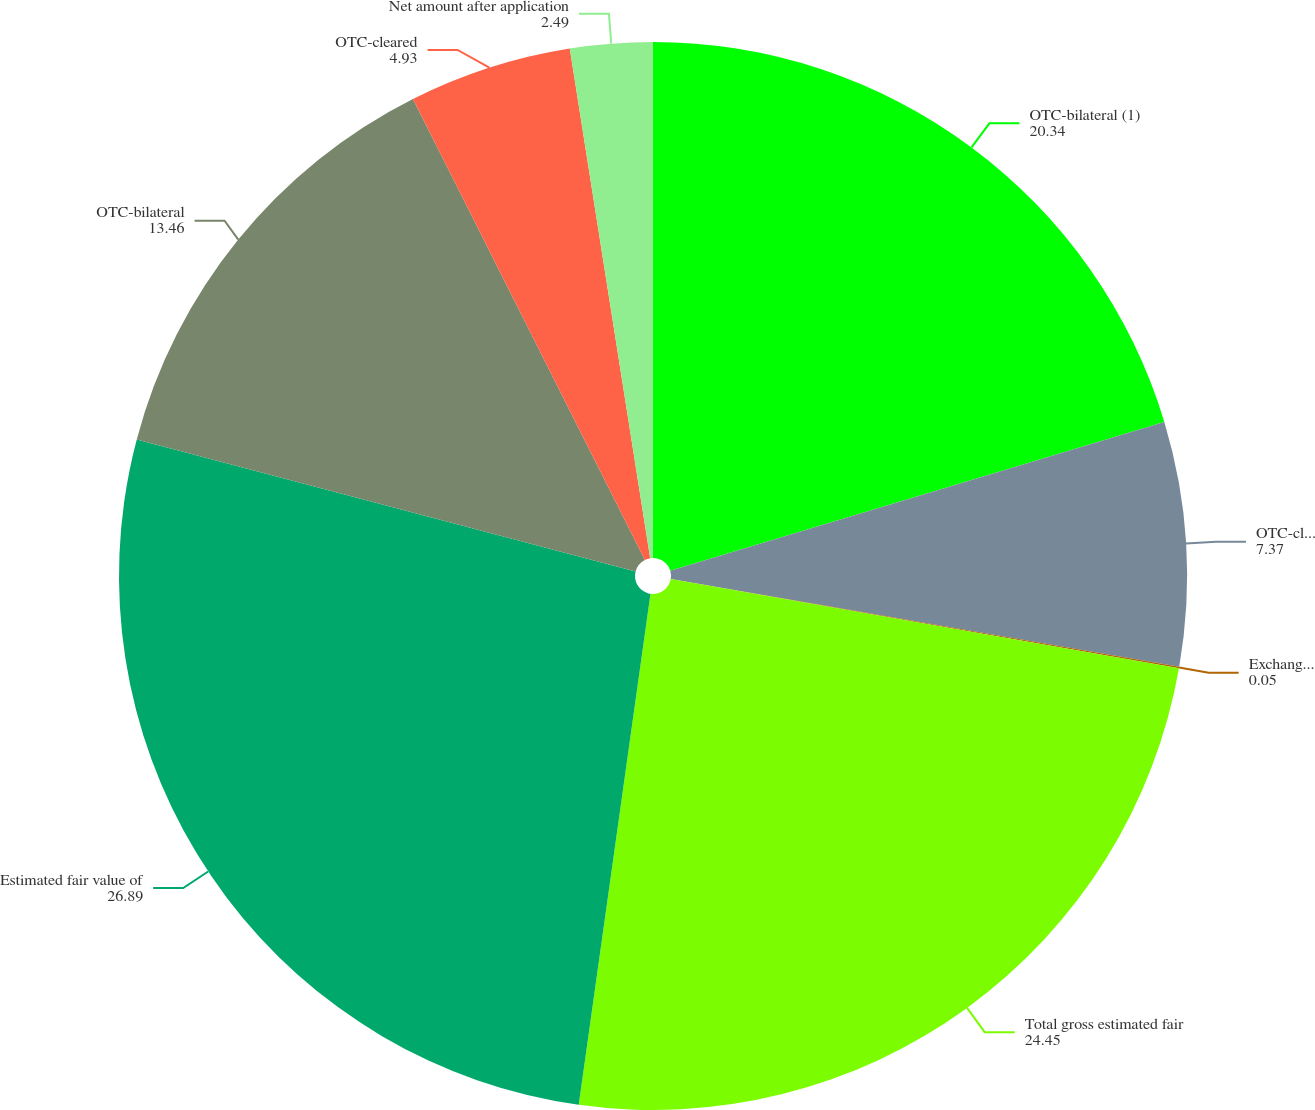Convert chart. <chart><loc_0><loc_0><loc_500><loc_500><pie_chart><fcel>OTC-bilateral (1)<fcel>OTC-cleared (1) (6)<fcel>Exchange-traded<fcel>Total gross estimated fair<fcel>Estimated fair value of<fcel>OTC-bilateral<fcel>OTC-cleared<fcel>Net amount after application<nl><fcel>20.34%<fcel>7.37%<fcel>0.05%<fcel>24.45%<fcel>26.89%<fcel>13.46%<fcel>4.93%<fcel>2.49%<nl></chart> 